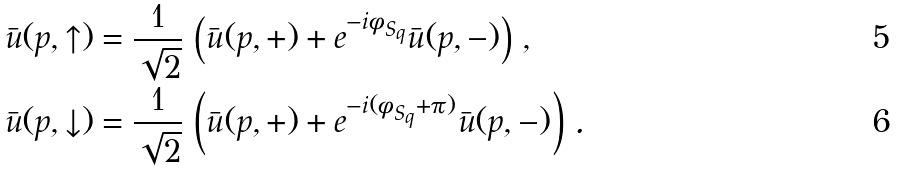Convert formula to latex. <formula><loc_0><loc_0><loc_500><loc_500>\bar { u } ( p , \uparrow ) & = \frac { 1 } { \sqrt { 2 } } \, \left ( \bar { u } ( p , + ) + e ^ { - i \phi _ { S _ { q } } } \bar { u } ( p , - ) \right ) \, , \\ \bar { u } ( p , \downarrow ) & = \frac { 1 } { \sqrt { 2 } } \, \left ( \bar { u } ( p , + ) + e ^ { - i ( \phi _ { S _ { q } } + \pi ) } \bar { u } ( p , - ) \right ) \, .</formula> 